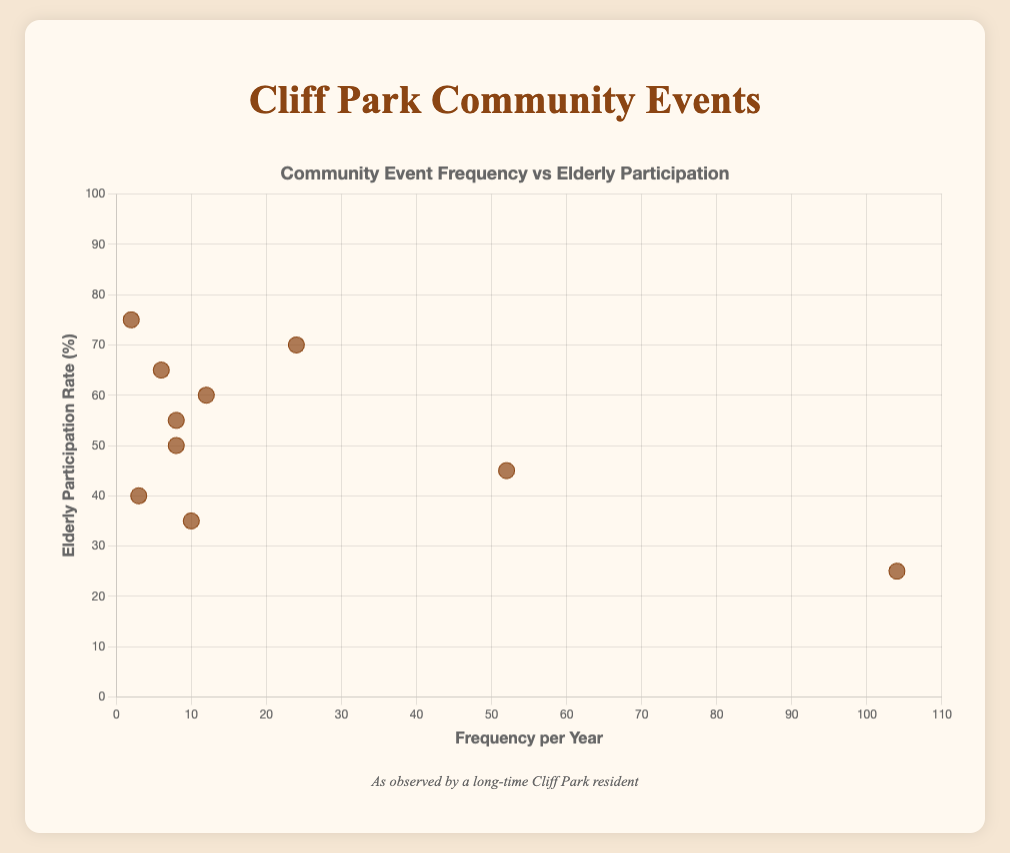What's the title of the figure? The title of the figure is displayed at the top and provides an overview of the data shown in the scatter plot. It reads 'Community Event Frequency vs Elderly Participation'.
Answer: Community Event Frequency vs Elderly Participation What are the labels of the x and y axes? The x-axis and y-axis labels provide context for the data points in the scatter plot. The x-axis is labeled 'Frequency per Year' and the y-axis is labeled 'Elderly Participation Rate (%)'.
Answer: Frequency per Year; Elderly Participation Rate (%) Which event has the highest yearly frequency? By looking at the x-axis values and identifying the data point farthest to the right, the 'Community Yoga Classes' is seen to have a frequency of 104 times per year, making it the highest.
Answer: Community Yoga Classes Which event has the highest elderly participation rate? The highest point on the y-axis corresponds to 'Holiday Parades,' which has an elderly participation rate of 75%.
Answer: Holiday Parades How many events occur more than 50 times a year? By counting the number of points with x-axis values greater than 50, we find two events: 'Weekly Farmers Market' and 'Community Yoga Classes.'
Answer: 2 What is the participation rate for events that occur less than 10 times a year? Looking at data points with x-axis values less than 10, the events and their elderly participation rates are: 'Art Exhibitions' (35%), 'Gardening Workshops' (55%), 'Music in the Park' (50%), 'Health and Wellness Seminars' (65%), 'Craft Fairs' (40%), and 'Holiday Parades' (75%).
Answer: 35%, 55%, 50%, 65%, 40%, 75% Is there an event that has both a low frequency and high participation rate? 'Holiday Parades' happens only 2 times a year (low frequency) but has a high elderly participation rate of 75%.
Answer: Yes, Holiday Parades What's the average elderly participation rate for events that occur more than 20 times a year? Adding up the participation rates of relevant events: 'Weekly Farmers Market' (45%), 'Community Yoga Classes' (25%), and 'Book Club Meetings' (70%) gives 45 + 25 + 70 = 140. Dividing by the number of events (3) results in 140/3 ≈ 46.67%.
Answer: 46.67% Compare the elderly participation rates of 'Weekly Farmers Market' and 'Community Yoga Classes.' Which has a higher rate? The participation rate for 'Weekly Farmers Market' is 45%, while for 'Community Yoga Classes' it is 25%. Therefore, 'Weekly Farmers Market' has a higher participation rate.
Answer: Weekly Farmers Market Which event has both a low participation rate and occurs very frequently? 'Community Yoga Classes' is the event that occurs very frequently (104 times per year) but has a relatively low participation rate of 25%.
Answer: Community Yoga Classes 